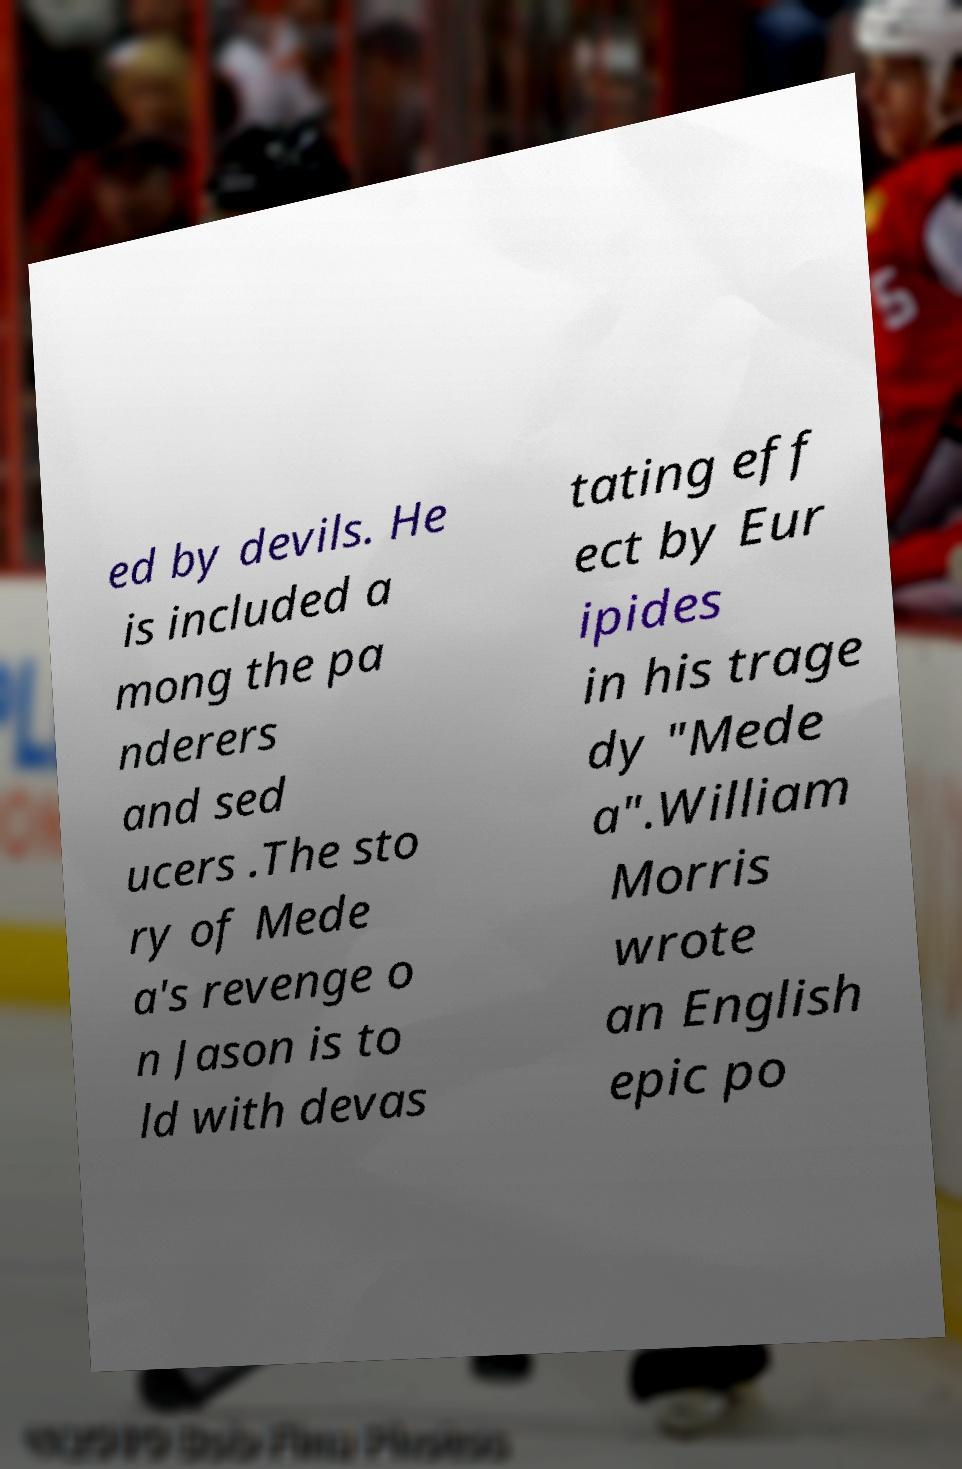Can you read and provide the text displayed in the image?This photo seems to have some interesting text. Can you extract and type it out for me? ed by devils. He is included a mong the pa nderers and sed ucers .The sto ry of Mede a's revenge o n Jason is to ld with devas tating eff ect by Eur ipides in his trage dy "Mede a".William Morris wrote an English epic po 